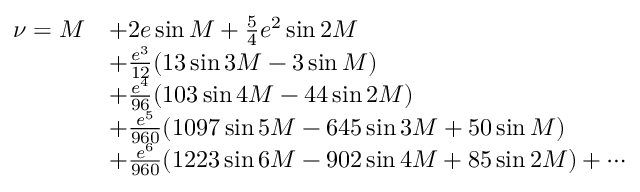Convert formula to latex. <formula><loc_0><loc_0><loc_500><loc_500>{ \begin{array} { r l } { \nu = M } & { + 2 e \sin M + { \frac { 5 } { 4 } } e ^ { 2 } \sin 2 M } \\ & { + { \frac { e ^ { 3 } } { 1 2 } } ( 1 3 \sin 3 M - 3 \sin M ) } \\ & { + { \frac { e ^ { 4 } } { 9 6 } } ( 1 0 3 \sin 4 M - 4 4 \sin 2 M ) } \\ & { + { \frac { e ^ { 5 } } { 9 6 0 } } ( 1 0 9 7 \sin 5 M - 6 4 5 \sin 3 M + 5 0 \sin M ) } \\ & { + { \frac { e ^ { 6 } } { 9 6 0 } } ( 1 2 2 3 \sin 6 M - 9 0 2 \sin 4 M + 8 5 \sin 2 M ) + \cdots } \end{array} }</formula> 